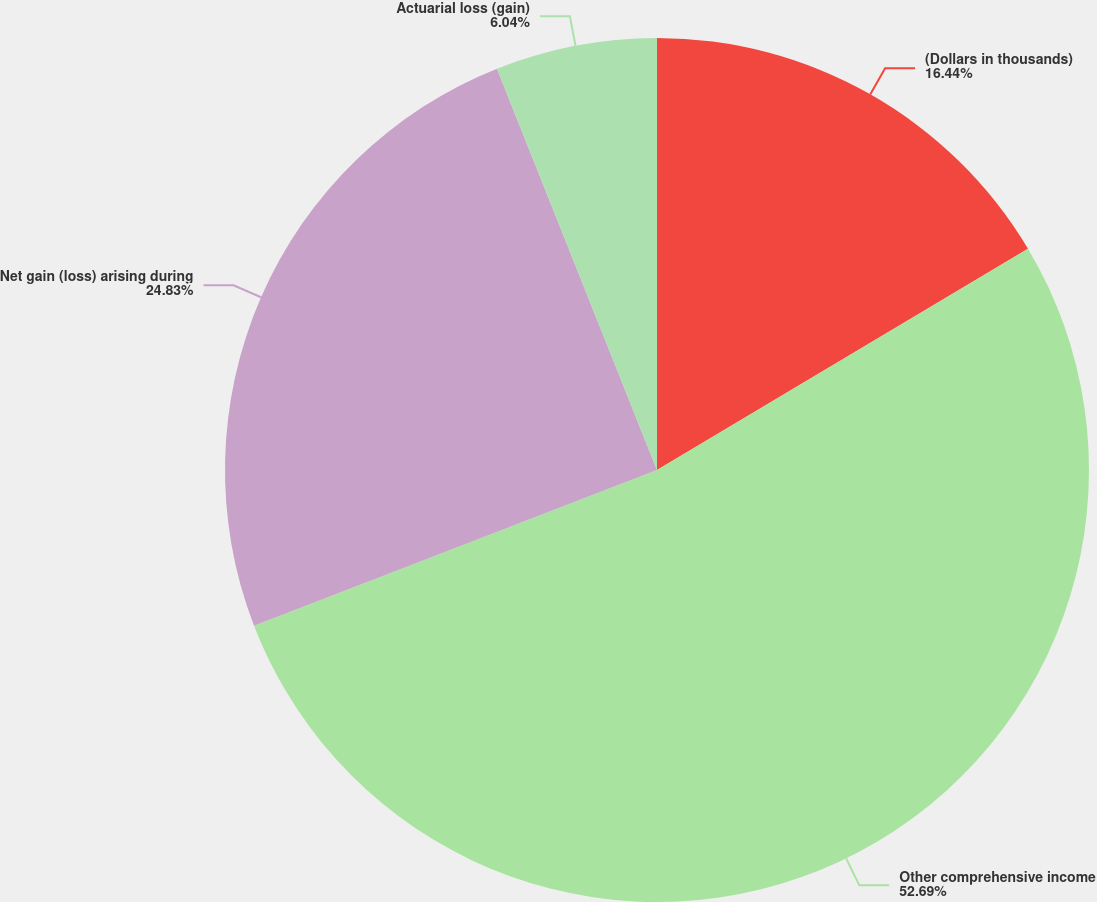<chart> <loc_0><loc_0><loc_500><loc_500><pie_chart><fcel>(Dollars in thousands)<fcel>Other comprehensive income<fcel>Net gain (loss) arising during<fcel>Actuarial loss (gain)<nl><fcel>16.44%<fcel>52.7%<fcel>24.83%<fcel>6.04%<nl></chart> 